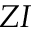Convert formula to latex. <formula><loc_0><loc_0><loc_500><loc_500>Z I</formula> 